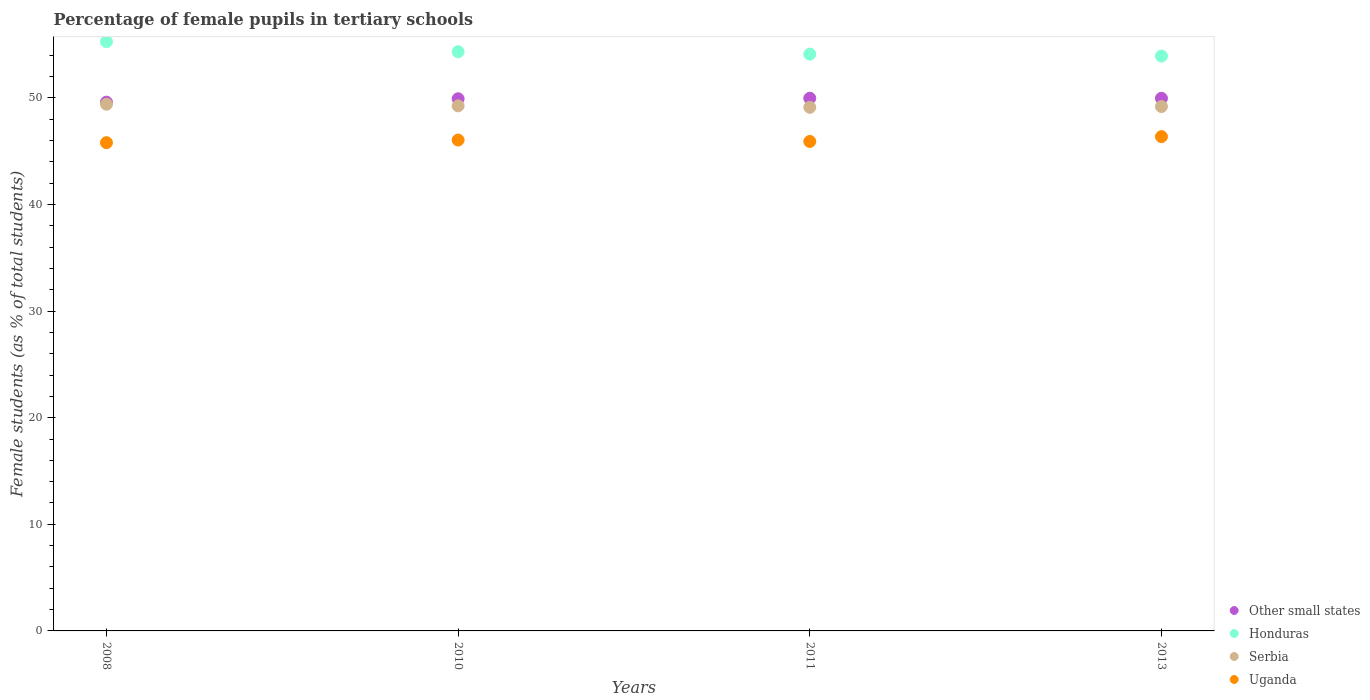How many different coloured dotlines are there?
Offer a terse response. 4. What is the percentage of female pupils in tertiary schools in Other small states in 2013?
Give a very brief answer. 49.96. Across all years, what is the maximum percentage of female pupils in tertiary schools in Serbia?
Provide a succinct answer. 49.4. Across all years, what is the minimum percentage of female pupils in tertiary schools in Uganda?
Your response must be concise. 45.79. In which year was the percentage of female pupils in tertiary schools in Other small states maximum?
Offer a terse response. 2011. In which year was the percentage of female pupils in tertiary schools in Serbia minimum?
Provide a short and direct response. 2011. What is the total percentage of female pupils in tertiary schools in Other small states in the graph?
Offer a very short reply. 199.43. What is the difference between the percentage of female pupils in tertiary schools in Uganda in 2008 and that in 2010?
Provide a succinct answer. -0.25. What is the difference between the percentage of female pupils in tertiary schools in Serbia in 2011 and the percentage of female pupils in tertiary schools in Honduras in 2013?
Offer a very short reply. -4.81. What is the average percentage of female pupils in tertiary schools in Other small states per year?
Your answer should be very brief. 49.86. In the year 2010, what is the difference between the percentage of female pupils in tertiary schools in Uganda and percentage of female pupils in tertiary schools in Honduras?
Keep it short and to the point. -8.28. What is the ratio of the percentage of female pupils in tertiary schools in Serbia in 2008 to that in 2011?
Offer a very short reply. 1.01. Is the percentage of female pupils in tertiary schools in Other small states in 2008 less than that in 2013?
Your answer should be compact. Yes. What is the difference between the highest and the second highest percentage of female pupils in tertiary schools in Honduras?
Offer a terse response. 0.95. What is the difference between the highest and the lowest percentage of female pupils in tertiary schools in Uganda?
Offer a very short reply. 0.57. In how many years, is the percentage of female pupils in tertiary schools in Other small states greater than the average percentage of female pupils in tertiary schools in Other small states taken over all years?
Provide a short and direct response. 3. Is the sum of the percentage of female pupils in tertiary schools in Uganda in 2011 and 2013 greater than the maximum percentage of female pupils in tertiary schools in Serbia across all years?
Provide a short and direct response. Yes. What is the difference between two consecutive major ticks on the Y-axis?
Ensure brevity in your answer.  10. Are the values on the major ticks of Y-axis written in scientific E-notation?
Offer a terse response. No. What is the title of the graph?
Your answer should be compact. Percentage of female pupils in tertiary schools. Does "Upper middle income" appear as one of the legend labels in the graph?
Your answer should be very brief. No. What is the label or title of the Y-axis?
Ensure brevity in your answer.  Female students (as % of total students). What is the Female students (as % of total students) in Other small states in 2008?
Ensure brevity in your answer.  49.6. What is the Female students (as % of total students) in Honduras in 2008?
Your answer should be compact. 55.27. What is the Female students (as % of total students) of Serbia in 2008?
Ensure brevity in your answer.  49.4. What is the Female students (as % of total students) in Uganda in 2008?
Make the answer very short. 45.79. What is the Female students (as % of total students) of Other small states in 2010?
Give a very brief answer. 49.91. What is the Female students (as % of total students) of Honduras in 2010?
Give a very brief answer. 54.33. What is the Female students (as % of total students) in Serbia in 2010?
Keep it short and to the point. 49.25. What is the Female students (as % of total students) in Uganda in 2010?
Keep it short and to the point. 46.04. What is the Female students (as % of total students) in Other small states in 2011?
Your answer should be very brief. 49.96. What is the Female students (as % of total students) in Honduras in 2011?
Provide a succinct answer. 54.1. What is the Female students (as % of total students) in Serbia in 2011?
Give a very brief answer. 49.11. What is the Female students (as % of total students) in Uganda in 2011?
Your response must be concise. 45.91. What is the Female students (as % of total students) of Other small states in 2013?
Offer a very short reply. 49.96. What is the Female students (as % of total students) in Honduras in 2013?
Give a very brief answer. 53.92. What is the Female students (as % of total students) of Serbia in 2013?
Provide a succinct answer. 49.18. What is the Female students (as % of total students) of Uganda in 2013?
Give a very brief answer. 46.36. Across all years, what is the maximum Female students (as % of total students) in Other small states?
Give a very brief answer. 49.96. Across all years, what is the maximum Female students (as % of total students) of Honduras?
Your answer should be very brief. 55.27. Across all years, what is the maximum Female students (as % of total students) of Serbia?
Make the answer very short. 49.4. Across all years, what is the maximum Female students (as % of total students) of Uganda?
Your answer should be compact. 46.36. Across all years, what is the minimum Female students (as % of total students) of Other small states?
Ensure brevity in your answer.  49.6. Across all years, what is the minimum Female students (as % of total students) of Honduras?
Keep it short and to the point. 53.92. Across all years, what is the minimum Female students (as % of total students) of Serbia?
Your answer should be compact. 49.11. Across all years, what is the minimum Female students (as % of total students) in Uganda?
Offer a very short reply. 45.79. What is the total Female students (as % of total students) in Other small states in the graph?
Offer a very short reply. 199.43. What is the total Female students (as % of total students) of Honduras in the graph?
Your response must be concise. 217.62. What is the total Female students (as % of total students) in Serbia in the graph?
Your answer should be very brief. 196.94. What is the total Female students (as % of total students) of Uganda in the graph?
Provide a short and direct response. 184.11. What is the difference between the Female students (as % of total students) in Other small states in 2008 and that in 2010?
Offer a terse response. -0.32. What is the difference between the Female students (as % of total students) of Honduras in 2008 and that in 2010?
Provide a succinct answer. 0.95. What is the difference between the Female students (as % of total students) in Serbia in 2008 and that in 2010?
Ensure brevity in your answer.  0.16. What is the difference between the Female students (as % of total students) in Uganda in 2008 and that in 2010?
Give a very brief answer. -0.25. What is the difference between the Female students (as % of total students) of Other small states in 2008 and that in 2011?
Your answer should be compact. -0.37. What is the difference between the Female students (as % of total students) in Honduras in 2008 and that in 2011?
Offer a terse response. 1.17. What is the difference between the Female students (as % of total students) in Serbia in 2008 and that in 2011?
Your answer should be compact. 0.29. What is the difference between the Female students (as % of total students) in Uganda in 2008 and that in 2011?
Provide a succinct answer. -0.11. What is the difference between the Female students (as % of total students) of Other small states in 2008 and that in 2013?
Offer a very short reply. -0.36. What is the difference between the Female students (as % of total students) in Honduras in 2008 and that in 2013?
Provide a short and direct response. 1.35. What is the difference between the Female students (as % of total students) of Serbia in 2008 and that in 2013?
Ensure brevity in your answer.  0.22. What is the difference between the Female students (as % of total students) of Uganda in 2008 and that in 2013?
Your answer should be compact. -0.57. What is the difference between the Female students (as % of total students) of Other small states in 2010 and that in 2011?
Provide a succinct answer. -0.05. What is the difference between the Female students (as % of total students) in Honduras in 2010 and that in 2011?
Provide a short and direct response. 0.22. What is the difference between the Female students (as % of total students) of Serbia in 2010 and that in 2011?
Your answer should be compact. 0.14. What is the difference between the Female students (as % of total students) of Uganda in 2010 and that in 2011?
Ensure brevity in your answer.  0.13. What is the difference between the Female students (as % of total students) of Other small states in 2010 and that in 2013?
Offer a very short reply. -0.05. What is the difference between the Female students (as % of total students) in Honduras in 2010 and that in 2013?
Provide a short and direct response. 0.41. What is the difference between the Female students (as % of total students) in Serbia in 2010 and that in 2013?
Offer a very short reply. 0.06. What is the difference between the Female students (as % of total students) in Uganda in 2010 and that in 2013?
Offer a terse response. -0.32. What is the difference between the Female students (as % of total students) of Other small states in 2011 and that in 2013?
Make the answer very short. 0. What is the difference between the Female students (as % of total students) in Honduras in 2011 and that in 2013?
Ensure brevity in your answer.  0.18. What is the difference between the Female students (as % of total students) of Serbia in 2011 and that in 2013?
Provide a short and direct response. -0.08. What is the difference between the Female students (as % of total students) of Uganda in 2011 and that in 2013?
Ensure brevity in your answer.  -0.45. What is the difference between the Female students (as % of total students) of Other small states in 2008 and the Female students (as % of total students) of Honduras in 2010?
Ensure brevity in your answer.  -4.73. What is the difference between the Female students (as % of total students) of Other small states in 2008 and the Female students (as % of total students) of Serbia in 2010?
Provide a succinct answer. 0.35. What is the difference between the Female students (as % of total students) of Other small states in 2008 and the Female students (as % of total students) of Uganda in 2010?
Keep it short and to the point. 3.55. What is the difference between the Female students (as % of total students) in Honduras in 2008 and the Female students (as % of total students) in Serbia in 2010?
Provide a short and direct response. 6.02. What is the difference between the Female students (as % of total students) in Honduras in 2008 and the Female students (as % of total students) in Uganda in 2010?
Your answer should be very brief. 9.23. What is the difference between the Female students (as % of total students) in Serbia in 2008 and the Female students (as % of total students) in Uganda in 2010?
Make the answer very short. 3.36. What is the difference between the Female students (as % of total students) of Other small states in 2008 and the Female students (as % of total students) of Honduras in 2011?
Ensure brevity in your answer.  -4.51. What is the difference between the Female students (as % of total students) of Other small states in 2008 and the Female students (as % of total students) of Serbia in 2011?
Your answer should be compact. 0.49. What is the difference between the Female students (as % of total students) of Other small states in 2008 and the Female students (as % of total students) of Uganda in 2011?
Provide a short and direct response. 3.69. What is the difference between the Female students (as % of total students) in Honduras in 2008 and the Female students (as % of total students) in Serbia in 2011?
Keep it short and to the point. 6.16. What is the difference between the Female students (as % of total students) in Honduras in 2008 and the Female students (as % of total students) in Uganda in 2011?
Your answer should be compact. 9.36. What is the difference between the Female students (as % of total students) of Serbia in 2008 and the Female students (as % of total students) of Uganda in 2011?
Make the answer very short. 3.49. What is the difference between the Female students (as % of total students) of Other small states in 2008 and the Female students (as % of total students) of Honduras in 2013?
Provide a succinct answer. -4.32. What is the difference between the Female students (as % of total students) of Other small states in 2008 and the Female students (as % of total students) of Serbia in 2013?
Your response must be concise. 0.41. What is the difference between the Female students (as % of total students) of Other small states in 2008 and the Female students (as % of total students) of Uganda in 2013?
Provide a succinct answer. 3.23. What is the difference between the Female students (as % of total students) in Honduras in 2008 and the Female students (as % of total students) in Serbia in 2013?
Provide a succinct answer. 6.09. What is the difference between the Female students (as % of total students) in Honduras in 2008 and the Female students (as % of total students) in Uganda in 2013?
Provide a short and direct response. 8.91. What is the difference between the Female students (as % of total students) of Serbia in 2008 and the Female students (as % of total students) of Uganda in 2013?
Make the answer very short. 3.04. What is the difference between the Female students (as % of total students) in Other small states in 2010 and the Female students (as % of total students) in Honduras in 2011?
Your answer should be very brief. -4.19. What is the difference between the Female students (as % of total students) in Other small states in 2010 and the Female students (as % of total students) in Serbia in 2011?
Your answer should be very brief. 0.8. What is the difference between the Female students (as % of total students) in Other small states in 2010 and the Female students (as % of total students) in Uganda in 2011?
Your answer should be compact. 4. What is the difference between the Female students (as % of total students) in Honduras in 2010 and the Female students (as % of total students) in Serbia in 2011?
Provide a succinct answer. 5.22. What is the difference between the Female students (as % of total students) of Honduras in 2010 and the Female students (as % of total students) of Uganda in 2011?
Your answer should be very brief. 8.42. What is the difference between the Female students (as % of total students) of Serbia in 2010 and the Female students (as % of total students) of Uganda in 2011?
Give a very brief answer. 3.34. What is the difference between the Female students (as % of total students) in Other small states in 2010 and the Female students (as % of total students) in Honduras in 2013?
Make the answer very short. -4.01. What is the difference between the Female students (as % of total students) of Other small states in 2010 and the Female students (as % of total students) of Serbia in 2013?
Offer a terse response. 0.73. What is the difference between the Female students (as % of total students) in Other small states in 2010 and the Female students (as % of total students) in Uganda in 2013?
Provide a succinct answer. 3.55. What is the difference between the Female students (as % of total students) in Honduras in 2010 and the Female students (as % of total students) in Serbia in 2013?
Provide a succinct answer. 5.14. What is the difference between the Female students (as % of total students) in Honduras in 2010 and the Female students (as % of total students) in Uganda in 2013?
Give a very brief answer. 7.96. What is the difference between the Female students (as % of total students) of Serbia in 2010 and the Female students (as % of total students) of Uganda in 2013?
Ensure brevity in your answer.  2.89. What is the difference between the Female students (as % of total students) of Other small states in 2011 and the Female students (as % of total students) of Honduras in 2013?
Your answer should be very brief. -3.96. What is the difference between the Female students (as % of total students) of Other small states in 2011 and the Female students (as % of total students) of Serbia in 2013?
Provide a succinct answer. 0.78. What is the difference between the Female students (as % of total students) in Other small states in 2011 and the Female students (as % of total students) in Uganda in 2013?
Offer a very short reply. 3.6. What is the difference between the Female students (as % of total students) in Honduras in 2011 and the Female students (as % of total students) in Serbia in 2013?
Ensure brevity in your answer.  4.92. What is the difference between the Female students (as % of total students) of Honduras in 2011 and the Female students (as % of total students) of Uganda in 2013?
Ensure brevity in your answer.  7.74. What is the difference between the Female students (as % of total students) of Serbia in 2011 and the Female students (as % of total students) of Uganda in 2013?
Ensure brevity in your answer.  2.75. What is the average Female students (as % of total students) in Other small states per year?
Provide a succinct answer. 49.86. What is the average Female students (as % of total students) of Honduras per year?
Provide a succinct answer. 54.41. What is the average Female students (as % of total students) in Serbia per year?
Offer a very short reply. 49.24. What is the average Female students (as % of total students) of Uganda per year?
Your answer should be compact. 46.03. In the year 2008, what is the difference between the Female students (as % of total students) of Other small states and Female students (as % of total students) of Honduras?
Give a very brief answer. -5.68. In the year 2008, what is the difference between the Female students (as % of total students) of Other small states and Female students (as % of total students) of Serbia?
Ensure brevity in your answer.  0.19. In the year 2008, what is the difference between the Female students (as % of total students) in Other small states and Female students (as % of total students) in Uganda?
Your answer should be compact. 3.8. In the year 2008, what is the difference between the Female students (as % of total students) in Honduras and Female students (as % of total students) in Serbia?
Give a very brief answer. 5.87. In the year 2008, what is the difference between the Female students (as % of total students) in Honduras and Female students (as % of total students) in Uganda?
Offer a very short reply. 9.48. In the year 2008, what is the difference between the Female students (as % of total students) in Serbia and Female students (as % of total students) in Uganda?
Provide a succinct answer. 3.61. In the year 2010, what is the difference between the Female students (as % of total students) of Other small states and Female students (as % of total students) of Honduras?
Make the answer very short. -4.41. In the year 2010, what is the difference between the Female students (as % of total students) of Other small states and Female students (as % of total students) of Serbia?
Your answer should be compact. 0.67. In the year 2010, what is the difference between the Female students (as % of total students) in Other small states and Female students (as % of total students) in Uganda?
Provide a succinct answer. 3.87. In the year 2010, what is the difference between the Female students (as % of total students) of Honduras and Female students (as % of total students) of Serbia?
Make the answer very short. 5.08. In the year 2010, what is the difference between the Female students (as % of total students) in Honduras and Female students (as % of total students) in Uganda?
Make the answer very short. 8.28. In the year 2010, what is the difference between the Female students (as % of total students) in Serbia and Female students (as % of total students) in Uganda?
Offer a very short reply. 3.21. In the year 2011, what is the difference between the Female students (as % of total students) of Other small states and Female students (as % of total students) of Honduras?
Ensure brevity in your answer.  -4.14. In the year 2011, what is the difference between the Female students (as % of total students) in Other small states and Female students (as % of total students) in Serbia?
Your response must be concise. 0.85. In the year 2011, what is the difference between the Female students (as % of total students) in Other small states and Female students (as % of total students) in Uganda?
Keep it short and to the point. 4.05. In the year 2011, what is the difference between the Female students (as % of total students) of Honduras and Female students (as % of total students) of Serbia?
Provide a succinct answer. 4.99. In the year 2011, what is the difference between the Female students (as % of total students) of Honduras and Female students (as % of total students) of Uganda?
Provide a short and direct response. 8.19. In the year 2011, what is the difference between the Female students (as % of total students) in Serbia and Female students (as % of total students) in Uganda?
Offer a very short reply. 3.2. In the year 2013, what is the difference between the Female students (as % of total students) in Other small states and Female students (as % of total students) in Honduras?
Offer a terse response. -3.96. In the year 2013, what is the difference between the Female students (as % of total students) in Other small states and Female students (as % of total students) in Serbia?
Give a very brief answer. 0.77. In the year 2013, what is the difference between the Female students (as % of total students) of Other small states and Female students (as % of total students) of Uganda?
Give a very brief answer. 3.6. In the year 2013, what is the difference between the Female students (as % of total students) in Honduras and Female students (as % of total students) in Serbia?
Ensure brevity in your answer.  4.74. In the year 2013, what is the difference between the Female students (as % of total students) of Honduras and Female students (as % of total students) of Uganda?
Your answer should be very brief. 7.56. In the year 2013, what is the difference between the Female students (as % of total students) of Serbia and Female students (as % of total students) of Uganda?
Provide a short and direct response. 2.82. What is the ratio of the Female students (as % of total students) in Other small states in 2008 to that in 2010?
Provide a succinct answer. 0.99. What is the ratio of the Female students (as % of total students) in Honduras in 2008 to that in 2010?
Provide a short and direct response. 1.02. What is the ratio of the Female students (as % of total students) of Serbia in 2008 to that in 2010?
Give a very brief answer. 1. What is the ratio of the Female students (as % of total students) in Other small states in 2008 to that in 2011?
Your answer should be compact. 0.99. What is the ratio of the Female students (as % of total students) in Honduras in 2008 to that in 2011?
Your answer should be compact. 1.02. What is the ratio of the Female students (as % of total students) of Serbia in 2008 to that in 2011?
Your answer should be very brief. 1.01. What is the ratio of the Female students (as % of total students) in Honduras in 2008 to that in 2013?
Ensure brevity in your answer.  1.03. What is the ratio of the Female students (as % of total students) in Serbia in 2008 to that in 2013?
Your answer should be very brief. 1. What is the ratio of the Female students (as % of total students) in Other small states in 2010 to that in 2013?
Give a very brief answer. 1. What is the ratio of the Female students (as % of total students) of Honduras in 2010 to that in 2013?
Ensure brevity in your answer.  1.01. What is the ratio of the Female students (as % of total students) in Serbia in 2010 to that in 2013?
Ensure brevity in your answer.  1. What is the ratio of the Female students (as % of total students) in Uganda in 2010 to that in 2013?
Give a very brief answer. 0.99. What is the ratio of the Female students (as % of total students) of Serbia in 2011 to that in 2013?
Provide a succinct answer. 1. What is the ratio of the Female students (as % of total students) of Uganda in 2011 to that in 2013?
Make the answer very short. 0.99. What is the difference between the highest and the second highest Female students (as % of total students) of Other small states?
Keep it short and to the point. 0. What is the difference between the highest and the second highest Female students (as % of total students) in Honduras?
Offer a terse response. 0.95. What is the difference between the highest and the second highest Female students (as % of total students) in Serbia?
Provide a succinct answer. 0.16. What is the difference between the highest and the second highest Female students (as % of total students) in Uganda?
Make the answer very short. 0.32. What is the difference between the highest and the lowest Female students (as % of total students) in Other small states?
Give a very brief answer. 0.37. What is the difference between the highest and the lowest Female students (as % of total students) in Honduras?
Keep it short and to the point. 1.35. What is the difference between the highest and the lowest Female students (as % of total students) of Serbia?
Make the answer very short. 0.29. What is the difference between the highest and the lowest Female students (as % of total students) of Uganda?
Make the answer very short. 0.57. 